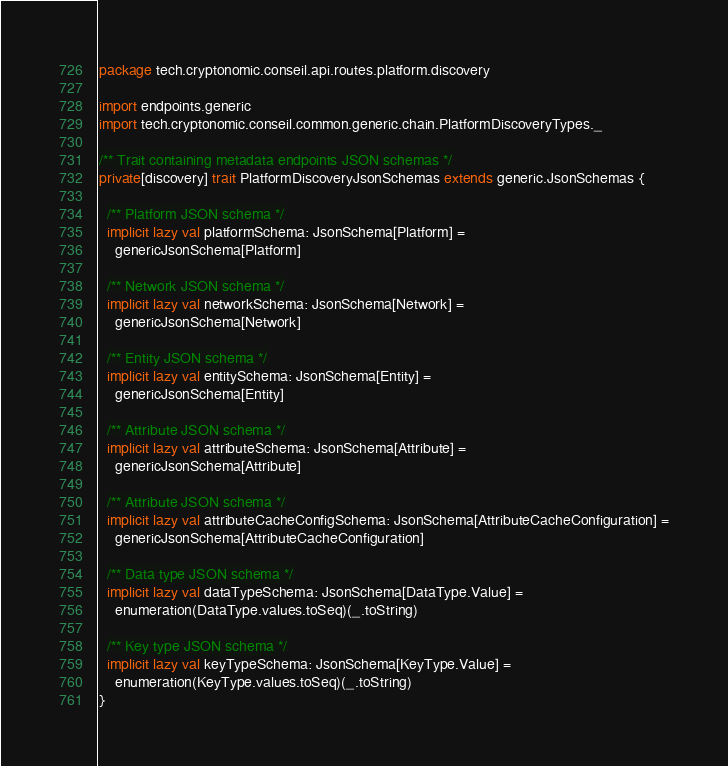Convert code to text. <code><loc_0><loc_0><loc_500><loc_500><_Scala_>package tech.cryptonomic.conseil.api.routes.platform.discovery

import endpoints.generic
import tech.cryptonomic.conseil.common.generic.chain.PlatformDiscoveryTypes._

/** Trait containing metadata endpoints JSON schemas */
private[discovery] trait PlatformDiscoveryJsonSchemas extends generic.JsonSchemas {

  /** Platform JSON schema */
  implicit lazy val platformSchema: JsonSchema[Platform] =
    genericJsonSchema[Platform]

  /** Network JSON schema */
  implicit lazy val networkSchema: JsonSchema[Network] =
    genericJsonSchema[Network]

  /** Entity JSON schema */
  implicit lazy val entitySchema: JsonSchema[Entity] =
    genericJsonSchema[Entity]

  /** Attribute JSON schema */
  implicit lazy val attributeSchema: JsonSchema[Attribute] =
    genericJsonSchema[Attribute]

  /** Attribute JSON schema */
  implicit lazy val attributeCacheConfigSchema: JsonSchema[AttributeCacheConfiguration] =
    genericJsonSchema[AttributeCacheConfiguration]

  /** Data type JSON schema */
  implicit lazy val dataTypeSchema: JsonSchema[DataType.Value] =
    enumeration(DataType.values.toSeq)(_.toString)

  /** Key type JSON schema */
  implicit lazy val keyTypeSchema: JsonSchema[KeyType.Value] =
    enumeration(KeyType.values.toSeq)(_.toString)
}
</code> 